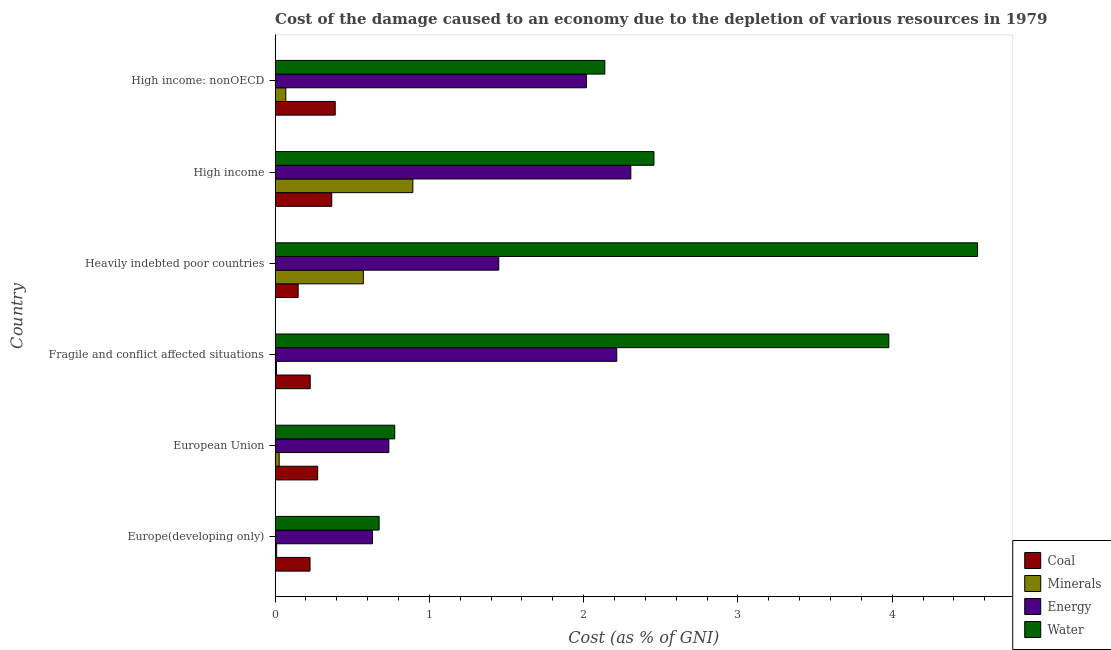How many different coloured bars are there?
Provide a short and direct response. 4. Are the number of bars per tick equal to the number of legend labels?
Your answer should be compact. Yes. How many bars are there on the 6th tick from the top?
Your answer should be very brief. 4. How many bars are there on the 6th tick from the bottom?
Provide a short and direct response. 4. What is the label of the 1st group of bars from the top?
Keep it short and to the point. High income: nonOECD. In how many cases, is the number of bars for a given country not equal to the number of legend labels?
Offer a terse response. 0. What is the cost of damage due to depletion of energy in European Union?
Your response must be concise. 0.74. Across all countries, what is the maximum cost of damage due to depletion of minerals?
Make the answer very short. 0.89. Across all countries, what is the minimum cost of damage due to depletion of water?
Your answer should be very brief. 0.67. In which country was the cost of damage due to depletion of coal maximum?
Offer a terse response. High income: nonOECD. In which country was the cost of damage due to depletion of coal minimum?
Your response must be concise. Heavily indebted poor countries. What is the total cost of damage due to depletion of coal in the graph?
Ensure brevity in your answer.  1.64. What is the difference between the cost of damage due to depletion of energy in Europe(developing only) and that in European Union?
Make the answer very short. -0.11. What is the difference between the cost of damage due to depletion of minerals in Europe(developing only) and the cost of damage due to depletion of energy in High income: nonOECD?
Give a very brief answer. -2.01. What is the average cost of damage due to depletion of coal per country?
Your answer should be compact. 0.27. What is the difference between the cost of damage due to depletion of water and cost of damage due to depletion of minerals in Europe(developing only)?
Ensure brevity in your answer.  0.66. What is the ratio of the cost of damage due to depletion of water in European Union to that in High income?
Keep it short and to the point. 0.32. What is the difference between the highest and the second highest cost of damage due to depletion of water?
Make the answer very short. 0.57. What is the difference between the highest and the lowest cost of damage due to depletion of minerals?
Keep it short and to the point. 0.88. In how many countries, is the cost of damage due to depletion of coal greater than the average cost of damage due to depletion of coal taken over all countries?
Your answer should be very brief. 3. What does the 3rd bar from the top in High income: nonOECD represents?
Make the answer very short. Minerals. What does the 1st bar from the bottom in Fragile and conflict affected situations represents?
Give a very brief answer. Coal. How many bars are there?
Ensure brevity in your answer.  24. Are all the bars in the graph horizontal?
Offer a terse response. Yes. Are the values on the major ticks of X-axis written in scientific E-notation?
Offer a very short reply. No. Does the graph contain grids?
Keep it short and to the point. No. Where does the legend appear in the graph?
Your answer should be compact. Bottom right. How many legend labels are there?
Make the answer very short. 4. What is the title of the graph?
Your answer should be compact. Cost of the damage caused to an economy due to the depletion of various resources in 1979 . Does "Finland" appear as one of the legend labels in the graph?
Keep it short and to the point. No. What is the label or title of the X-axis?
Offer a terse response. Cost (as % of GNI). What is the Cost (as % of GNI) in Coal in Europe(developing only)?
Offer a very short reply. 0.23. What is the Cost (as % of GNI) in Minerals in Europe(developing only)?
Keep it short and to the point. 0.01. What is the Cost (as % of GNI) of Energy in Europe(developing only)?
Offer a terse response. 0.63. What is the Cost (as % of GNI) in Water in Europe(developing only)?
Ensure brevity in your answer.  0.67. What is the Cost (as % of GNI) in Coal in European Union?
Ensure brevity in your answer.  0.28. What is the Cost (as % of GNI) in Minerals in European Union?
Your answer should be compact. 0.03. What is the Cost (as % of GNI) in Energy in European Union?
Make the answer very short. 0.74. What is the Cost (as % of GNI) in Water in European Union?
Offer a terse response. 0.78. What is the Cost (as % of GNI) in Coal in Fragile and conflict affected situations?
Your response must be concise. 0.23. What is the Cost (as % of GNI) in Minerals in Fragile and conflict affected situations?
Make the answer very short. 0.01. What is the Cost (as % of GNI) in Energy in Fragile and conflict affected situations?
Offer a very short reply. 2.21. What is the Cost (as % of GNI) of Water in Fragile and conflict affected situations?
Ensure brevity in your answer.  3.98. What is the Cost (as % of GNI) in Coal in Heavily indebted poor countries?
Your answer should be compact. 0.15. What is the Cost (as % of GNI) in Minerals in Heavily indebted poor countries?
Provide a succinct answer. 0.57. What is the Cost (as % of GNI) in Energy in Heavily indebted poor countries?
Provide a short and direct response. 1.45. What is the Cost (as % of GNI) in Water in Heavily indebted poor countries?
Offer a terse response. 4.55. What is the Cost (as % of GNI) in Coal in High income?
Your answer should be compact. 0.37. What is the Cost (as % of GNI) in Minerals in High income?
Ensure brevity in your answer.  0.89. What is the Cost (as % of GNI) in Energy in High income?
Keep it short and to the point. 2.31. What is the Cost (as % of GNI) in Water in High income?
Your answer should be very brief. 2.46. What is the Cost (as % of GNI) in Coal in High income: nonOECD?
Offer a very short reply. 0.39. What is the Cost (as % of GNI) of Minerals in High income: nonOECD?
Your answer should be very brief. 0.07. What is the Cost (as % of GNI) of Energy in High income: nonOECD?
Provide a short and direct response. 2.02. What is the Cost (as % of GNI) of Water in High income: nonOECD?
Ensure brevity in your answer.  2.14. Across all countries, what is the maximum Cost (as % of GNI) in Coal?
Your answer should be very brief. 0.39. Across all countries, what is the maximum Cost (as % of GNI) in Minerals?
Offer a very short reply. 0.89. Across all countries, what is the maximum Cost (as % of GNI) of Energy?
Your answer should be compact. 2.31. Across all countries, what is the maximum Cost (as % of GNI) in Water?
Provide a short and direct response. 4.55. Across all countries, what is the minimum Cost (as % of GNI) of Coal?
Offer a terse response. 0.15. Across all countries, what is the minimum Cost (as % of GNI) in Minerals?
Offer a very short reply. 0.01. Across all countries, what is the minimum Cost (as % of GNI) in Energy?
Offer a very short reply. 0.63. Across all countries, what is the minimum Cost (as % of GNI) in Water?
Give a very brief answer. 0.67. What is the total Cost (as % of GNI) in Coal in the graph?
Offer a terse response. 1.64. What is the total Cost (as % of GNI) in Minerals in the graph?
Keep it short and to the point. 1.58. What is the total Cost (as % of GNI) in Energy in the graph?
Your answer should be very brief. 9.36. What is the total Cost (as % of GNI) of Water in the graph?
Provide a short and direct response. 14.57. What is the difference between the Cost (as % of GNI) of Coal in Europe(developing only) and that in European Union?
Offer a very short reply. -0.05. What is the difference between the Cost (as % of GNI) of Minerals in Europe(developing only) and that in European Union?
Offer a terse response. -0.02. What is the difference between the Cost (as % of GNI) of Energy in Europe(developing only) and that in European Union?
Your response must be concise. -0.11. What is the difference between the Cost (as % of GNI) in Water in Europe(developing only) and that in European Union?
Ensure brevity in your answer.  -0.1. What is the difference between the Cost (as % of GNI) of Coal in Europe(developing only) and that in Fragile and conflict affected situations?
Your answer should be very brief. -0. What is the difference between the Cost (as % of GNI) in Minerals in Europe(developing only) and that in Fragile and conflict affected situations?
Provide a short and direct response. 0. What is the difference between the Cost (as % of GNI) of Energy in Europe(developing only) and that in Fragile and conflict affected situations?
Your response must be concise. -1.58. What is the difference between the Cost (as % of GNI) of Water in Europe(developing only) and that in Fragile and conflict affected situations?
Give a very brief answer. -3.3. What is the difference between the Cost (as % of GNI) in Coal in Europe(developing only) and that in Heavily indebted poor countries?
Make the answer very short. 0.08. What is the difference between the Cost (as % of GNI) of Minerals in Europe(developing only) and that in Heavily indebted poor countries?
Provide a succinct answer. -0.56. What is the difference between the Cost (as % of GNI) in Energy in Europe(developing only) and that in Heavily indebted poor countries?
Your answer should be very brief. -0.82. What is the difference between the Cost (as % of GNI) in Water in Europe(developing only) and that in Heavily indebted poor countries?
Offer a very short reply. -3.88. What is the difference between the Cost (as % of GNI) of Coal in Europe(developing only) and that in High income?
Offer a very short reply. -0.14. What is the difference between the Cost (as % of GNI) of Minerals in Europe(developing only) and that in High income?
Provide a short and direct response. -0.88. What is the difference between the Cost (as % of GNI) in Energy in Europe(developing only) and that in High income?
Offer a very short reply. -1.67. What is the difference between the Cost (as % of GNI) of Water in Europe(developing only) and that in High income?
Make the answer very short. -1.78. What is the difference between the Cost (as % of GNI) of Coal in Europe(developing only) and that in High income: nonOECD?
Offer a terse response. -0.16. What is the difference between the Cost (as % of GNI) in Minerals in Europe(developing only) and that in High income: nonOECD?
Provide a short and direct response. -0.06. What is the difference between the Cost (as % of GNI) of Energy in Europe(developing only) and that in High income: nonOECD?
Your answer should be very brief. -1.39. What is the difference between the Cost (as % of GNI) of Water in Europe(developing only) and that in High income: nonOECD?
Give a very brief answer. -1.46. What is the difference between the Cost (as % of GNI) of Coal in European Union and that in Fragile and conflict affected situations?
Your response must be concise. 0.05. What is the difference between the Cost (as % of GNI) of Minerals in European Union and that in Fragile and conflict affected situations?
Offer a terse response. 0.02. What is the difference between the Cost (as % of GNI) in Energy in European Union and that in Fragile and conflict affected situations?
Keep it short and to the point. -1.48. What is the difference between the Cost (as % of GNI) of Water in European Union and that in Fragile and conflict affected situations?
Give a very brief answer. -3.2. What is the difference between the Cost (as % of GNI) of Coal in European Union and that in Heavily indebted poor countries?
Provide a succinct answer. 0.13. What is the difference between the Cost (as % of GNI) in Minerals in European Union and that in Heavily indebted poor countries?
Offer a very short reply. -0.55. What is the difference between the Cost (as % of GNI) in Energy in European Union and that in Heavily indebted poor countries?
Offer a terse response. -0.71. What is the difference between the Cost (as % of GNI) of Water in European Union and that in Heavily indebted poor countries?
Your response must be concise. -3.78. What is the difference between the Cost (as % of GNI) in Coal in European Union and that in High income?
Your answer should be compact. -0.09. What is the difference between the Cost (as % of GNI) in Minerals in European Union and that in High income?
Your answer should be very brief. -0.87. What is the difference between the Cost (as % of GNI) in Energy in European Union and that in High income?
Your response must be concise. -1.57. What is the difference between the Cost (as % of GNI) in Water in European Union and that in High income?
Ensure brevity in your answer.  -1.68. What is the difference between the Cost (as % of GNI) of Coal in European Union and that in High income: nonOECD?
Keep it short and to the point. -0.11. What is the difference between the Cost (as % of GNI) of Minerals in European Union and that in High income: nonOECD?
Give a very brief answer. -0.04. What is the difference between the Cost (as % of GNI) of Energy in European Union and that in High income: nonOECD?
Provide a short and direct response. -1.28. What is the difference between the Cost (as % of GNI) of Water in European Union and that in High income: nonOECD?
Offer a very short reply. -1.36. What is the difference between the Cost (as % of GNI) in Coal in Fragile and conflict affected situations and that in Heavily indebted poor countries?
Your response must be concise. 0.08. What is the difference between the Cost (as % of GNI) of Minerals in Fragile and conflict affected situations and that in Heavily indebted poor countries?
Offer a terse response. -0.56. What is the difference between the Cost (as % of GNI) of Energy in Fragile and conflict affected situations and that in Heavily indebted poor countries?
Provide a succinct answer. 0.76. What is the difference between the Cost (as % of GNI) in Water in Fragile and conflict affected situations and that in Heavily indebted poor countries?
Your answer should be compact. -0.58. What is the difference between the Cost (as % of GNI) of Coal in Fragile and conflict affected situations and that in High income?
Ensure brevity in your answer.  -0.14. What is the difference between the Cost (as % of GNI) in Minerals in Fragile and conflict affected situations and that in High income?
Keep it short and to the point. -0.88. What is the difference between the Cost (as % of GNI) of Energy in Fragile and conflict affected situations and that in High income?
Offer a very short reply. -0.09. What is the difference between the Cost (as % of GNI) of Water in Fragile and conflict affected situations and that in High income?
Offer a terse response. 1.52. What is the difference between the Cost (as % of GNI) of Coal in Fragile and conflict affected situations and that in High income: nonOECD?
Your response must be concise. -0.16. What is the difference between the Cost (as % of GNI) of Minerals in Fragile and conflict affected situations and that in High income: nonOECD?
Make the answer very short. -0.06. What is the difference between the Cost (as % of GNI) in Energy in Fragile and conflict affected situations and that in High income: nonOECD?
Offer a terse response. 0.2. What is the difference between the Cost (as % of GNI) of Water in Fragile and conflict affected situations and that in High income: nonOECD?
Your answer should be compact. 1.84. What is the difference between the Cost (as % of GNI) in Coal in Heavily indebted poor countries and that in High income?
Keep it short and to the point. -0.22. What is the difference between the Cost (as % of GNI) of Minerals in Heavily indebted poor countries and that in High income?
Make the answer very short. -0.32. What is the difference between the Cost (as % of GNI) in Energy in Heavily indebted poor countries and that in High income?
Give a very brief answer. -0.86. What is the difference between the Cost (as % of GNI) in Water in Heavily indebted poor countries and that in High income?
Your answer should be compact. 2.1. What is the difference between the Cost (as % of GNI) in Coal in Heavily indebted poor countries and that in High income: nonOECD?
Ensure brevity in your answer.  -0.24. What is the difference between the Cost (as % of GNI) of Minerals in Heavily indebted poor countries and that in High income: nonOECD?
Keep it short and to the point. 0.5. What is the difference between the Cost (as % of GNI) of Energy in Heavily indebted poor countries and that in High income: nonOECD?
Offer a very short reply. -0.57. What is the difference between the Cost (as % of GNI) of Water in Heavily indebted poor countries and that in High income: nonOECD?
Keep it short and to the point. 2.42. What is the difference between the Cost (as % of GNI) of Coal in High income and that in High income: nonOECD?
Provide a short and direct response. -0.02. What is the difference between the Cost (as % of GNI) in Minerals in High income and that in High income: nonOECD?
Provide a succinct answer. 0.82. What is the difference between the Cost (as % of GNI) in Energy in High income and that in High income: nonOECD?
Your response must be concise. 0.29. What is the difference between the Cost (as % of GNI) in Water in High income and that in High income: nonOECD?
Give a very brief answer. 0.32. What is the difference between the Cost (as % of GNI) of Coal in Europe(developing only) and the Cost (as % of GNI) of Minerals in European Union?
Your answer should be compact. 0.2. What is the difference between the Cost (as % of GNI) in Coal in Europe(developing only) and the Cost (as % of GNI) in Energy in European Union?
Your answer should be compact. -0.51. What is the difference between the Cost (as % of GNI) of Coal in Europe(developing only) and the Cost (as % of GNI) of Water in European Union?
Keep it short and to the point. -0.55. What is the difference between the Cost (as % of GNI) in Minerals in Europe(developing only) and the Cost (as % of GNI) in Energy in European Union?
Make the answer very short. -0.73. What is the difference between the Cost (as % of GNI) in Minerals in Europe(developing only) and the Cost (as % of GNI) in Water in European Union?
Keep it short and to the point. -0.77. What is the difference between the Cost (as % of GNI) of Energy in Europe(developing only) and the Cost (as % of GNI) of Water in European Union?
Provide a succinct answer. -0.14. What is the difference between the Cost (as % of GNI) of Coal in Europe(developing only) and the Cost (as % of GNI) of Minerals in Fragile and conflict affected situations?
Provide a succinct answer. 0.22. What is the difference between the Cost (as % of GNI) in Coal in Europe(developing only) and the Cost (as % of GNI) in Energy in Fragile and conflict affected situations?
Provide a short and direct response. -1.99. What is the difference between the Cost (as % of GNI) of Coal in Europe(developing only) and the Cost (as % of GNI) of Water in Fragile and conflict affected situations?
Ensure brevity in your answer.  -3.75. What is the difference between the Cost (as % of GNI) in Minerals in Europe(developing only) and the Cost (as % of GNI) in Energy in Fragile and conflict affected situations?
Keep it short and to the point. -2.2. What is the difference between the Cost (as % of GNI) of Minerals in Europe(developing only) and the Cost (as % of GNI) of Water in Fragile and conflict affected situations?
Provide a short and direct response. -3.97. What is the difference between the Cost (as % of GNI) of Energy in Europe(developing only) and the Cost (as % of GNI) of Water in Fragile and conflict affected situations?
Provide a short and direct response. -3.35. What is the difference between the Cost (as % of GNI) of Coal in Europe(developing only) and the Cost (as % of GNI) of Minerals in Heavily indebted poor countries?
Ensure brevity in your answer.  -0.35. What is the difference between the Cost (as % of GNI) in Coal in Europe(developing only) and the Cost (as % of GNI) in Energy in Heavily indebted poor countries?
Provide a short and direct response. -1.22. What is the difference between the Cost (as % of GNI) of Coal in Europe(developing only) and the Cost (as % of GNI) of Water in Heavily indebted poor countries?
Ensure brevity in your answer.  -4.33. What is the difference between the Cost (as % of GNI) in Minerals in Europe(developing only) and the Cost (as % of GNI) in Energy in Heavily indebted poor countries?
Your answer should be compact. -1.44. What is the difference between the Cost (as % of GNI) in Minerals in Europe(developing only) and the Cost (as % of GNI) in Water in Heavily indebted poor countries?
Keep it short and to the point. -4.54. What is the difference between the Cost (as % of GNI) of Energy in Europe(developing only) and the Cost (as % of GNI) of Water in Heavily indebted poor countries?
Give a very brief answer. -3.92. What is the difference between the Cost (as % of GNI) in Coal in Europe(developing only) and the Cost (as % of GNI) in Minerals in High income?
Your response must be concise. -0.67. What is the difference between the Cost (as % of GNI) in Coal in Europe(developing only) and the Cost (as % of GNI) in Energy in High income?
Your response must be concise. -2.08. What is the difference between the Cost (as % of GNI) in Coal in Europe(developing only) and the Cost (as % of GNI) in Water in High income?
Make the answer very short. -2.23. What is the difference between the Cost (as % of GNI) of Minerals in Europe(developing only) and the Cost (as % of GNI) of Energy in High income?
Offer a very short reply. -2.3. What is the difference between the Cost (as % of GNI) of Minerals in Europe(developing only) and the Cost (as % of GNI) of Water in High income?
Offer a terse response. -2.45. What is the difference between the Cost (as % of GNI) of Energy in Europe(developing only) and the Cost (as % of GNI) of Water in High income?
Your answer should be very brief. -1.82. What is the difference between the Cost (as % of GNI) in Coal in Europe(developing only) and the Cost (as % of GNI) in Minerals in High income: nonOECD?
Keep it short and to the point. 0.16. What is the difference between the Cost (as % of GNI) in Coal in Europe(developing only) and the Cost (as % of GNI) in Energy in High income: nonOECD?
Offer a terse response. -1.79. What is the difference between the Cost (as % of GNI) in Coal in Europe(developing only) and the Cost (as % of GNI) in Water in High income: nonOECD?
Give a very brief answer. -1.91. What is the difference between the Cost (as % of GNI) of Minerals in Europe(developing only) and the Cost (as % of GNI) of Energy in High income: nonOECD?
Provide a succinct answer. -2.01. What is the difference between the Cost (as % of GNI) of Minerals in Europe(developing only) and the Cost (as % of GNI) of Water in High income: nonOECD?
Your answer should be compact. -2.13. What is the difference between the Cost (as % of GNI) of Energy in Europe(developing only) and the Cost (as % of GNI) of Water in High income: nonOECD?
Give a very brief answer. -1.51. What is the difference between the Cost (as % of GNI) in Coal in European Union and the Cost (as % of GNI) in Minerals in Fragile and conflict affected situations?
Provide a succinct answer. 0.27. What is the difference between the Cost (as % of GNI) of Coal in European Union and the Cost (as % of GNI) of Energy in Fragile and conflict affected situations?
Offer a very short reply. -1.94. What is the difference between the Cost (as % of GNI) in Coal in European Union and the Cost (as % of GNI) in Water in Fragile and conflict affected situations?
Provide a short and direct response. -3.7. What is the difference between the Cost (as % of GNI) in Minerals in European Union and the Cost (as % of GNI) in Energy in Fragile and conflict affected situations?
Make the answer very short. -2.19. What is the difference between the Cost (as % of GNI) in Minerals in European Union and the Cost (as % of GNI) in Water in Fragile and conflict affected situations?
Ensure brevity in your answer.  -3.95. What is the difference between the Cost (as % of GNI) of Energy in European Union and the Cost (as % of GNI) of Water in Fragile and conflict affected situations?
Give a very brief answer. -3.24. What is the difference between the Cost (as % of GNI) in Coal in European Union and the Cost (as % of GNI) in Minerals in Heavily indebted poor countries?
Keep it short and to the point. -0.3. What is the difference between the Cost (as % of GNI) of Coal in European Union and the Cost (as % of GNI) of Energy in Heavily indebted poor countries?
Your response must be concise. -1.17. What is the difference between the Cost (as % of GNI) in Coal in European Union and the Cost (as % of GNI) in Water in Heavily indebted poor countries?
Offer a terse response. -4.28. What is the difference between the Cost (as % of GNI) in Minerals in European Union and the Cost (as % of GNI) in Energy in Heavily indebted poor countries?
Your answer should be compact. -1.42. What is the difference between the Cost (as % of GNI) in Minerals in European Union and the Cost (as % of GNI) in Water in Heavily indebted poor countries?
Ensure brevity in your answer.  -4.53. What is the difference between the Cost (as % of GNI) of Energy in European Union and the Cost (as % of GNI) of Water in Heavily indebted poor countries?
Offer a terse response. -3.82. What is the difference between the Cost (as % of GNI) in Coal in European Union and the Cost (as % of GNI) in Minerals in High income?
Offer a terse response. -0.62. What is the difference between the Cost (as % of GNI) in Coal in European Union and the Cost (as % of GNI) in Energy in High income?
Keep it short and to the point. -2.03. What is the difference between the Cost (as % of GNI) of Coal in European Union and the Cost (as % of GNI) of Water in High income?
Make the answer very short. -2.18. What is the difference between the Cost (as % of GNI) in Minerals in European Union and the Cost (as % of GNI) in Energy in High income?
Provide a short and direct response. -2.28. What is the difference between the Cost (as % of GNI) in Minerals in European Union and the Cost (as % of GNI) in Water in High income?
Keep it short and to the point. -2.43. What is the difference between the Cost (as % of GNI) in Energy in European Union and the Cost (as % of GNI) in Water in High income?
Ensure brevity in your answer.  -1.72. What is the difference between the Cost (as % of GNI) in Coal in European Union and the Cost (as % of GNI) in Minerals in High income: nonOECD?
Your answer should be compact. 0.21. What is the difference between the Cost (as % of GNI) in Coal in European Union and the Cost (as % of GNI) in Energy in High income: nonOECD?
Provide a succinct answer. -1.74. What is the difference between the Cost (as % of GNI) of Coal in European Union and the Cost (as % of GNI) of Water in High income: nonOECD?
Make the answer very short. -1.86. What is the difference between the Cost (as % of GNI) in Minerals in European Union and the Cost (as % of GNI) in Energy in High income: nonOECD?
Give a very brief answer. -1.99. What is the difference between the Cost (as % of GNI) in Minerals in European Union and the Cost (as % of GNI) in Water in High income: nonOECD?
Offer a terse response. -2.11. What is the difference between the Cost (as % of GNI) of Energy in European Union and the Cost (as % of GNI) of Water in High income: nonOECD?
Provide a succinct answer. -1.4. What is the difference between the Cost (as % of GNI) of Coal in Fragile and conflict affected situations and the Cost (as % of GNI) of Minerals in Heavily indebted poor countries?
Ensure brevity in your answer.  -0.34. What is the difference between the Cost (as % of GNI) in Coal in Fragile and conflict affected situations and the Cost (as % of GNI) in Energy in Heavily indebted poor countries?
Make the answer very short. -1.22. What is the difference between the Cost (as % of GNI) of Coal in Fragile and conflict affected situations and the Cost (as % of GNI) of Water in Heavily indebted poor countries?
Offer a very short reply. -4.33. What is the difference between the Cost (as % of GNI) in Minerals in Fragile and conflict affected situations and the Cost (as % of GNI) in Energy in Heavily indebted poor countries?
Offer a terse response. -1.44. What is the difference between the Cost (as % of GNI) in Minerals in Fragile and conflict affected situations and the Cost (as % of GNI) in Water in Heavily indebted poor countries?
Make the answer very short. -4.54. What is the difference between the Cost (as % of GNI) in Energy in Fragile and conflict affected situations and the Cost (as % of GNI) in Water in Heavily indebted poor countries?
Offer a very short reply. -2.34. What is the difference between the Cost (as % of GNI) of Coal in Fragile and conflict affected situations and the Cost (as % of GNI) of Minerals in High income?
Your response must be concise. -0.67. What is the difference between the Cost (as % of GNI) of Coal in Fragile and conflict affected situations and the Cost (as % of GNI) of Energy in High income?
Your answer should be compact. -2.08. What is the difference between the Cost (as % of GNI) of Coal in Fragile and conflict affected situations and the Cost (as % of GNI) of Water in High income?
Provide a succinct answer. -2.23. What is the difference between the Cost (as % of GNI) of Minerals in Fragile and conflict affected situations and the Cost (as % of GNI) of Energy in High income?
Offer a very short reply. -2.3. What is the difference between the Cost (as % of GNI) in Minerals in Fragile and conflict affected situations and the Cost (as % of GNI) in Water in High income?
Your response must be concise. -2.45. What is the difference between the Cost (as % of GNI) in Energy in Fragile and conflict affected situations and the Cost (as % of GNI) in Water in High income?
Provide a short and direct response. -0.24. What is the difference between the Cost (as % of GNI) of Coal in Fragile and conflict affected situations and the Cost (as % of GNI) of Minerals in High income: nonOECD?
Ensure brevity in your answer.  0.16. What is the difference between the Cost (as % of GNI) in Coal in Fragile and conflict affected situations and the Cost (as % of GNI) in Energy in High income: nonOECD?
Offer a terse response. -1.79. What is the difference between the Cost (as % of GNI) of Coal in Fragile and conflict affected situations and the Cost (as % of GNI) of Water in High income: nonOECD?
Provide a short and direct response. -1.91. What is the difference between the Cost (as % of GNI) in Minerals in Fragile and conflict affected situations and the Cost (as % of GNI) in Energy in High income: nonOECD?
Provide a succinct answer. -2.01. What is the difference between the Cost (as % of GNI) in Minerals in Fragile and conflict affected situations and the Cost (as % of GNI) in Water in High income: nonOECD?
Your answer should be compact. -2.13. What is the difference between the Cost (as % of GNI) in Energy in Fragile and conflict affected situations and the Cost (as % of GNI) in Water in High income: nonOECD?
Your answer should be very brief. 0.08. What is the difference between the Cost (as % of GNI) of Coal in Heavily indebted poor countries and the Cost (as % of GNI) of Minerals in High income?
Provide a succinct answer. -0.74. What is the difference between the Cost (as % of GNI) of Coal in Heavily indebted poor countries and the Cost (as % of GNI) of Energy in High income?
Ensure brevity in your answer.  -2.16. What is the difference between the Cost (as % of GNI) in Coal in Heavily indebted poor countries and the Cost (as % of GNI) in Water in High income?
Keep it short and to the point. -2.31. What is the difference between the Cost (as % of GNI) of Minerals in Heavily indebted poor countries and the Cost (as % of GNI) of Energy in High income?
Offer a terse response. -1.73. What is the difference between the Cost (as % of GNI) of Minerals in Heavily indebted poor countries and the Cost (as % of GNI) of Water in High income?
Offer a terse response. -1.88. What is the difference between the Cost (as % of GNI) of Energy in Heavily indebted poor countries and the Cost (as % of GNI) of Water in High income?
Your answer should be very brief. -1.01. What is the difference between the Cost (as % of GNI) in Coal in Heavily indebted poor countries and the Cost (as % of GNI) in Minerals in High income: nonOECD?
Provide a short and direct response. 0.08. What is the difference between the Cost (as % of GNI) in Coal in Heavily indebted poor countries and the Cost (as % of GNI) in Energy in High income: nonOECD?
Your response must be concise. -1.87. What is the difference between the Cost (as % of GNI) of Coal in Heavily indebted poor countries and the Cost (as % of GNI) of Water in High income: nonOECD?
Offer a terse response. -1.99. What is the difference between the Cost (as % of GNI) in Minerals in Heavily indebted poor countries and the Cost (as % of GNI) in Energy in High income: nonOECD?
Keep it short and to the point. -1.45. What is the difference between the Cost (as % of GNI) of Minerals in Heavily indebted poor countries and the Cost (as % of GNI) of Water in High income: nonOECD?
Make the answer very short. -1.57. What is the difference between the Cost (as % of GNI) in Energy in Heavily indebted poor countries and the Cost (as % of GNI) in Water in High income: nonOECD?
Keep it short and to the point. -0.69. What is the difference between the Cost (as % of GNI) in Coal in High income and the Cost (as % of GNI) in Minerals in High income: nonOECD?
Offer a very short reply. 0.3. What is the difference between the Cost (as % of GNI) of Coal in High income and the Cost (as % of GNI) of Energy in High income: nonOECD?
Your answer should be very brief. -1.65. What is the difference between the Cost (as % of GNI) of Coal in High income and the Cost (as % of GNI) of Water in High income: nonOECD?
Give a very brief answer. -1.77. What is the difference between the Cost (as % of GNI) of Minerals in High income and the Cost (as % of GNI) of Energy in High income: nonOECD?
Your response must be concise. -1.12. What is the difference between the Cost (as % of GNI) in Minerals in High income and the Cost (as % of GNI) in Water in High income: nonOECD?
Your answer should be compact. -1.24. What is the difference between the Cost (as % of GNI) of Energy in High income and the Cost (as % of GNI) of Water in High income: nonOECD?
Your answer should be very brief. 0.17. What is the average Cost (as % of GNI) in Coal per country?
Make the answer very short. 0.27. What is the average Cost (as % of GNI) of Minerals per country?
Your response must be concise. 0.26. What is the average Cost (as % of GNI) of Energy per country?
Make the answer very short. 1.56. What is the average Cost (as % of GNI) in Water per country?
Ensure brevity in your answer.  2.43. What is the difference between the Cost (as % of GNI) in Coal and Cost (as % of GNI) in Minerals in Europe(developing only)?
Keep it short and to the point. 0.22. What is the difference between the Cost (as % of GNI) in Coal and Cost (as % of GNI) in Energy in Europe(developing only)?
Your response must be concise. -0.4. What is the difference between the Cost (as % of GNI) in Coal and Cost (as % of GNI) in Water in Europe(developing only)?
Your answer should be very brief. -0.45. What is the difference between the Cost (as % of GNI) in Minerals and Cost (as % of GNI) in Energy in Europe(developing only)?
Ensure brevity in your answer.  -0.62. What is the difference between the Cost (as % of GNI) in Minerals and Cost (as % of GNI) in Water in Europe(developing only)?
Offer a terse response. -0.66. What is the difference between the Cost (as % of GNI) in Energy and Cost (as % of GNI) in Water in Europe(developing only)?
Keep it short and to the point. -0.04. What is the difference between the Cost (as % of GNI) in Coal and Cost (as % of GNI) in Minerals in European Union?
Keep it short and to the point. 0.25. What is the difference between the Cost (as % of GNI) in Coal and Cost (as % of GNI) in Energy in European Union?
Your response must be concise. -0.46. What is the difference between the Cost (as % of GNI) of Coal and Cost (as % of GNI) of Water in European Union?
Offer a very short reply. -0.5. What is the difference between the Cost (as % of GNI) of Minerals and Cost (as % of GNI) of Energy in European Union?
Provide a succinct answer. -0.71. What is the difference between the Cost (as % of GNI) in Minerals and Cost (as % of GNI) in Water in European Union?
Offer a very short reply. -0.75. What is the difference between the Cost (as % of GNI) of Energy and Cost (as % of GNI) of Water in European Union?
Offer a very short reply. -0.04. What is the difference between the Cost (as % of GNI) in Coal and Cost (as % of GNI) in Minerals in Fragile and conflict affected situations?
Make the answer very short. 0.22. What is the difference between the Cost (as % of GNI) of Coal and Cost (as % of GNI) of Energy in Fragile and conflict affected situations?
Your answer should be compact. -1.99. What is the difference between the Cost (as % of GNI) in Coal and Cost (as % of GNI) in Water in Fragile and conflict affected situations?
Provide a succinct answer. -3.75. What is the difference between the Cost (as % of GNI) of Minerals and Cost (as % of GNI) of Energy in Fragile and conflict affected situations?
Your answer should be very brief. -2.21. What is the difference between the Cost (as % of GNI) of Minerals and Cost (as % of GNI) of Water in Fragile and conflict affected situations?
Offer a terse response. -3.97. What is the difference between the Cost (as % of GNI) in Energy and Cost (as % of GNI) in Water in Fragile and conflict affected situations?
Give a very brief answer. -1.76. What is the difference between the Cost (as % of GNI) of Coal and Cost (as % of GNI) of Minerals in Heavily indebted poor countries?
Make the answer very short. -0.42. What is the difference between the Cost (as % of GNI) in Coal and Cost (as % of GNI) in Energy in Heavily indebted poor countries?
Provide a succinct answer. -1.3. What is the difference between the Cost (as % of GNI) of Coal and Cost (as % of GNI) of Water in Heavily indebted poor countries?
Keep it short and to the point. -4.4. What is the difference between the Cost (as % of GNI) in Minerals and Cost (as % of GNI) in Energy in Heavily indebted poor countries?
Keep it short and to the point. -0.88. What is the difference between the Cost (as % of GNI) in Minerals and Cost (as % of GNI) in Water in Heavily indebted poor countries?
Ensure brevity in your answer.  -3.98. What is the difference between the Cost (as % of GNI) in Energy and Cost (as % of GNI) in Water in Heavily indebted poor countries?
Ensure brevity in your answer.  -3.1. What is the difference between the Cost (as % of GNI) of Coal and Cost (as % of GNI) of Minerals in High income?
Give a very brief answer. -0.53. What is the difference between the Cost (as % of GNI) of Coal and Cost (as % of GNI) of Energy in High income?
Offer a very short reply. -1.94. What is the difference between the Cost (as % of GNI) of Coal and Cost (as % of GNI) of Water in High income?
Provide a succinct answer. -2.09. What is the difference between the Cost (as % of GNI) of Minerals and Cost (as % of GNI) of Energy in High income?
Give a very brief answer. -1.41. What is the difference between the Cost (as % of GNI) of Minerals and Cost (as % of GNI) of Water in High income?
Give a very brief answer. -1.56. What is the difference between the Cost (as % of GNI) of Energy and Cost (as % of GNI) of Water in High income?
Provide a short and direct response. -0.15. What is the difference between the Cost (as % of GNI) of Coal and Cost (as % of GNI) of Minerals in High income: nonOECD?
Your response must be concise. 0.32. What is the difference between the Cost (as % of GNI) of Coal and Cost (as % of GNI) of Energy in High income: nonOECD?
Your response must be concise. -1.63. What is the difference between the Cost (as % of GNI) in Coal and Cost (as % of GNI) in Water in High income: nonOECD?
Provide a succinct answer. -1.75. What is the difference between the Cost (as % of GNI) in Minerals and Cost (as % of GNI) in Energy in High income: nonOECD?
Your response must be concise. -1.95. What is the difference between the Cost (as % of GNI) in Minerals and Cost (as % of GNI) in Water in High income: nonOECD?
Provide a succinct answer. -2.07. What is the difference between the Cost (as % of GNI) in Energy and Cost (as % of GNI) in Water in High income: nonOECD?
Keep it short and to the point. -0.12. What is the ratio of the Cost (as % of GNI) of Coal in Europe(developing only) to that in European Union?
Offer a terse response. 0.82. What is the ratio of the Cost (as % of GNI) in Minerals in Europe(developing only) to that in European Union?
Your answer should be compact. 0.38. What is the ratio of the Cost (as % of GNI) in Energy in Europe(developing only) to that in European Union?
Your response must be concise. 0.86. What is the ratio of the Cost (as % of GNI) of Water in Europe(developing only) to that in European Union?
Give a very brief answer. 0.87. What is the ratio of the Cost (as % of GNI) of Coal in Europe(developing only) to that in Fragile and conflict affected situations?
Give a very brief answer. 0.99. What is the ratio of the Cost (as % of GNI) in Minerals in Europe(developing only) to that in Fragile and conflict affected situations?
Ensure brevity in your answer.  1.09. What is the ratio of the Cost (as % of GNI) of Energy in Europe(developing only) to that in Fragile and conflict affected situations?
Your response must be concise. 0.28. What is the ratio of the Cost (as % of GNI) of Water in Europe(developing only) to that in Fragile and conflict affected situations?
Your answer should be very brief. 0.17. What is the ratio of the Cost (as % of GNI) of Coal in Europe(developing only) to that in Heavily indebted poor countries?
Your response must be concise. 1.51. What is the ratio of the Cost (as % of GNI) in Minerals in Europe(developing only) to that in Heavily indebted poor countries?
Make the answer very short. 0.02. What is the ratio of the Cost (as % of GNI) in Energy in Europe(developing only) to that in Heavily indebted poor countries?
Offer a very short reply. 0.44. What is the ratio of the Cost (as % of GNI) in Water in Europe(developing only) to that in Heavily indebted poor countries?
Ensure brevity in your answer.  0.15. What is the ratio of the Cost (as % of GNI) of Coal in Europe(developing only) to that in High income?
Keep it short and to the point. 0.62. What is the ratio of the Cost (as % of GNI) of Minerals in Europe(developing only) to that in High income?
Offer a very short reply. 0.01. What is the ratio of the Cost (as % of GNI) of Energy in Europe(developing only) to that in High income?
Keep it short and to the point. 0.27. What is the ratio of the Cost (as % of GNI) of Water in Europe(developing only) to that in High income?
Your answer should be compact. 0.27. What is the ratio of the Cost (as % of GNI) in Coal in Europe(developing only) to that in High income: nonOECD?
Your answer should be compact. 0.58. What is the ratio of the Cost (as % of GNI) in Minerals in Europe(developing only) to that in High income: nonOECD?
Ensure brevity in your answer.  0.14. What is the ratio of the Cost (as % of GNI) of Energy in Europe(developing only) to that in High income: nonOECD?
Provide a short and direct response. 0.31. What is the ratio of the Cost (as % of GNI) of Water in Europe(developing only) to that in High income: nonOECD?
Your answer should be very brief. 0.32. What is the ratio of the Cost (as % of GNI) in Coal in European Union to that in Fragile and conflict affected situations?
Your answer should be compact. 1.21. What is the ratio of the Cost (as % of GNI) of Minerals in European Union to that in Fragile and conflict affected situations?
Your response must be concise. 2.87. What is the ratio of the Cost (as % of GNI) in Energy in European Union to that in Fragile and conflict affected situations?
Your answer should be very brief. 0.33. What is the ratio of the Cost (as % of GNI) of Water in European Union to that in Fragile and conflict affected situations?
Your answer should be compact. 0.2. What is the ratio of the Cost (as % of GNI) of Coal in European Union to that in Heavily indebted poor countries?
Provide a succinct answer. 1.85. What is the ratio of the Cost (as % of GNI) of Minerals in European Union to that in Heavily indebted poor countries?
Your response must be concise. 0.05. What is the ratio of the Cost (as % of GNI) in Energy in European Union to that in Heavily indebted poor countries?
Give a very brief answer. 0.51. What is the ratio of the Cost (as % of GNI) in Water in European Union to that in Heavily indebted poor countries?
Offer a very short reply. 0.17. What is the ratio of the Cost (as % of GNI) in Coal in European Union to that in High income?
Ensure brevity in your answer.  0.75. What is the ratio of the Cost (as % of GNI) of Minerals in European Union to that in High income?
Your answer should be very brief. 0.03. What is the ratio of the Cost (as % of GNI) of Energy in European Union to that in High income?
Your answer should be compact. 0.32. What is the ratio of the Cost (as % of GNI) of Water in European Union to that in High income?
Offer a terse response. 0.32. What is the ratio of the Cost (as % of GNI) in Coal in European Union to that in High income: nonOECD?
Your answer should be very brief. 0.71. What is the ratio of the Cost (as % of GNI) in Minerals in European Union to that in High income: nonOECD?
Give a very brief answer. 0.38. What is the ratio of the Cost (as % of GNI) of Energy in European Union to that in High income: nonOECD?
Keep it short and to the point. 0.37. What is the ratio of the Cost (as % of GNI) of Water in European Union to that in High income: nonOECD?
Your response must be concise. 0.36. What is the ratio of the Cost (as % of GNI) in Coal in Fragile and conflict affected situations to that in Heavily indebted poor countries?
Offer a terse response. 1.52. What is the ratio of the Cost (as % of GNI) of Minerals in Fragile and conflict affected situations to that in Heavily indebted poor countries?
Offer a terse response. 0.02. What is the ratio of the Cost (as % of GNI) in Energy in Fragile and conflict affected situations to that in Heavily indebted poor countries?
Your answer should be compact. 1.53. What is the ratio of the Cost (as % of GNI) of Water in Fragile and conflict affected situations to that in Heavily indebted poor countries?
Offer a terse response. 0.87. What is the ratio of the Cost (as % of GNI) in Coal in Fragile and conflict affected situations to that in High income?
Keep it short and to the point. 0.62. What is the ratio of the Cost (as % of GNI) in Minerals in Fragile and conflict affected situations to that in High income?
Your response must be concise. 0.01. What is the ratio of the Cost (as % of GNI) of Energy in Fragile and conflict affected situations to that in High income?
Ensure brevity in your answer.  0.96. What is the ratio of the Cost (as % of GNI) in Water in Fragile and conflict affected situations to that in High income?
Ensure brevity in your answer.  1.62. What is the ratio of the Cost (as % of GNI) in Coal in Fragile and conflict affected situations to that in High income: nonOECD?
Provide a succinct answer. 0.58. What is the ratio of the Cost (as % of GNI) in Minerals in Fragile and conflict affected situations to that in High income: nonOECD?
Offer a very short reply. 0.13. What is the ratio of the Cost (as % of GNI) of Energy in Fragile and conflict affected situations to that in High income: nonOECD?
Provide a succinct answer. 1.1. What is the ratio of the Cost (as % of GNI) of Water in Fragile and conflict affected situations to that in High income: nonOECD?
Your answer should be very brief. 1.86. What is the ratio of the Cost (as % of GNI) of Coal in Heavily indebted poor countries to that in High income?
Provide a short and direct response. 0.41. What is the ratio of the Cost (as % of GNI) of Minerals in Heavily indebted poor countries to that in High income?
Your answer should be very brief. 0.64. What is the ratio of the Cost (as % of GNI) of Energy in Heavily indebted poor countries to that in High income?
Keep it short and to the point. 0.63. What is the ratio of the Cost (as % of GNI) of Water in Heavily indebted poor countries to that in High income?
Keep it short and to the point. 1.85. What is the ratio of the Cost (as % of GNI) of Coal in Heavily indebted poor countries to that in High income: nonOECD?
Make the answer very short. 0.38. What is the ratio of the Cost (as % of GNI) of Minerals in Heavily indebted poor countries to that in High income: nonOECD?
Your response must be concise. 8.22. What is the ratio of the Cost (as % of GNI) of Energy in Heavily indebted poor countries to that in High income: nonOECD?
Give a very brief answer. 0.72. What is the ratio of the Cost (as % of GNI) in Water in Heavily indebted poor countries to that in High income: nonOECD?
Keep it short and to the point. 2.13. What is the ratio of the Cost (as % of GNI) of Coal in High income to that in High income: nonOECD?
Provide a short and direct response. 0.94. What is the ratio of the Cost (as % of GNI) in Minerals in High income to that in High income: nonOECD?
Provide a short and direct response. 12.83. What is the ratio of the Cost (as % of GNI) in Energy in High income to that in High income: nonOECD?
Give a very brief answer. 1.14. What is the ratio of the Cost (as % of GNI) in Water in High income to that in High income: nonOECD?
Provide a succinct answer. 1.15. What is the difference between the highest and the second highest Cost (as % of GNI) of Coal?
Offer a terse response. 0.02. What is the difference between the highest and the second highest Cost (as % of GNI) of Minerals?
Offer a terse response. 0.32. What is the difference between the highest and the second highest Cost (as % of GNI) in Energy?
Give a very brief answer. 0.09. What is the difference between the highest and the second highest Cost (as % of GNI) in Water?
Make the answer very short. 0.58. What is the difference between the highest and the lowest Cost (as % of GNI) of Coal?
Your answer should be very brief. 0.24. What is the difference between the highest and the lowest Cost (as % of GNI) in Minerals?
Offer a terse response. 0.88. What is the difference between the highest and the lowest Cost (as % of GNI) of Energy?
Your response must be concise. 1.67. What is the difference between the highest and the lowest Cost (as % of GNI) of Water?
Your answer should be very brief. 3.88. 